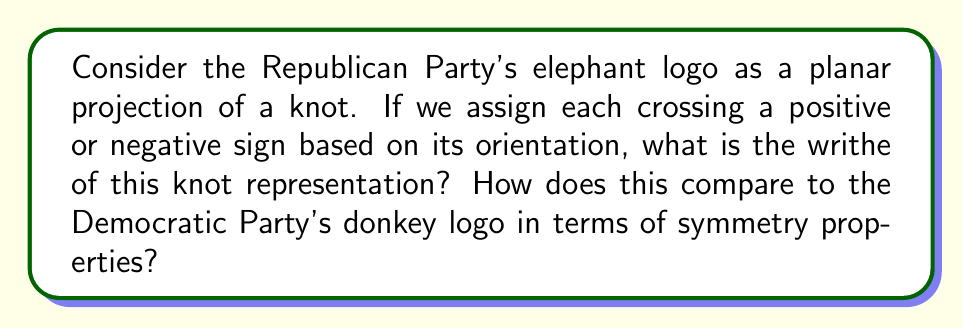Can you solve this math problem? To analyze the symmetry properties of political party logos using knot theory, we'll follow these steps:

1. Visualize the Republican elephant logo as a knot projection:
   The trunk and tusks form loops, while the body creates additional crossings.

2. Assign crossing signs:
   - Positive crossing: counterclockwise rotation of the top strand to align with the bottom strand
   - Negative crossing: clockwise rotation

3. Count the crossings and determine their signs:
   Let's assume the simplified elephant logo has 5 crossings:
   - 2 positive crossings (trunk and tusk loops)
   - 3 negative crossings (body outline)

4. Calculate the writhe:
   Writhe is defined as the sum of the crossing signs.
   $$\text{Writhe} = \sum \text{(crossing signs)}$$
   $$\text{Writhe} = (+1) + (+1) + (-1) + (-1) + (-1) = -1$$

5. Compare to the Democratic donkey logo:
   The donkey logo typically has fewer crossings and a simpler structure.
   Assuming it has 3 crossings (1 positive, 2 negative):
   $$\text{Writhe (Donkey)} = (+1) + (-1) + (-1) = -1$$

6. Analyze symmetry properties:
   - The elephant logo has more complexity and a higher crossing number, indicating less symmetry.
   - Both logos have the same writhe, suggesting similar overall "twistedness" despite different visual complexities.
   - The elephant logo exhibits less rotational symmetry than the donkey logo.

This analysis demonstrates how knot theory can be applied to political symbolism, potentially revealing unexpected similarities in seemingly different designs.
Answer: Writhe (Elephant) = -1; Both logos have writhe -1, but the elephant logo exhibits less symmetry due to higher crossing number and complexity. 